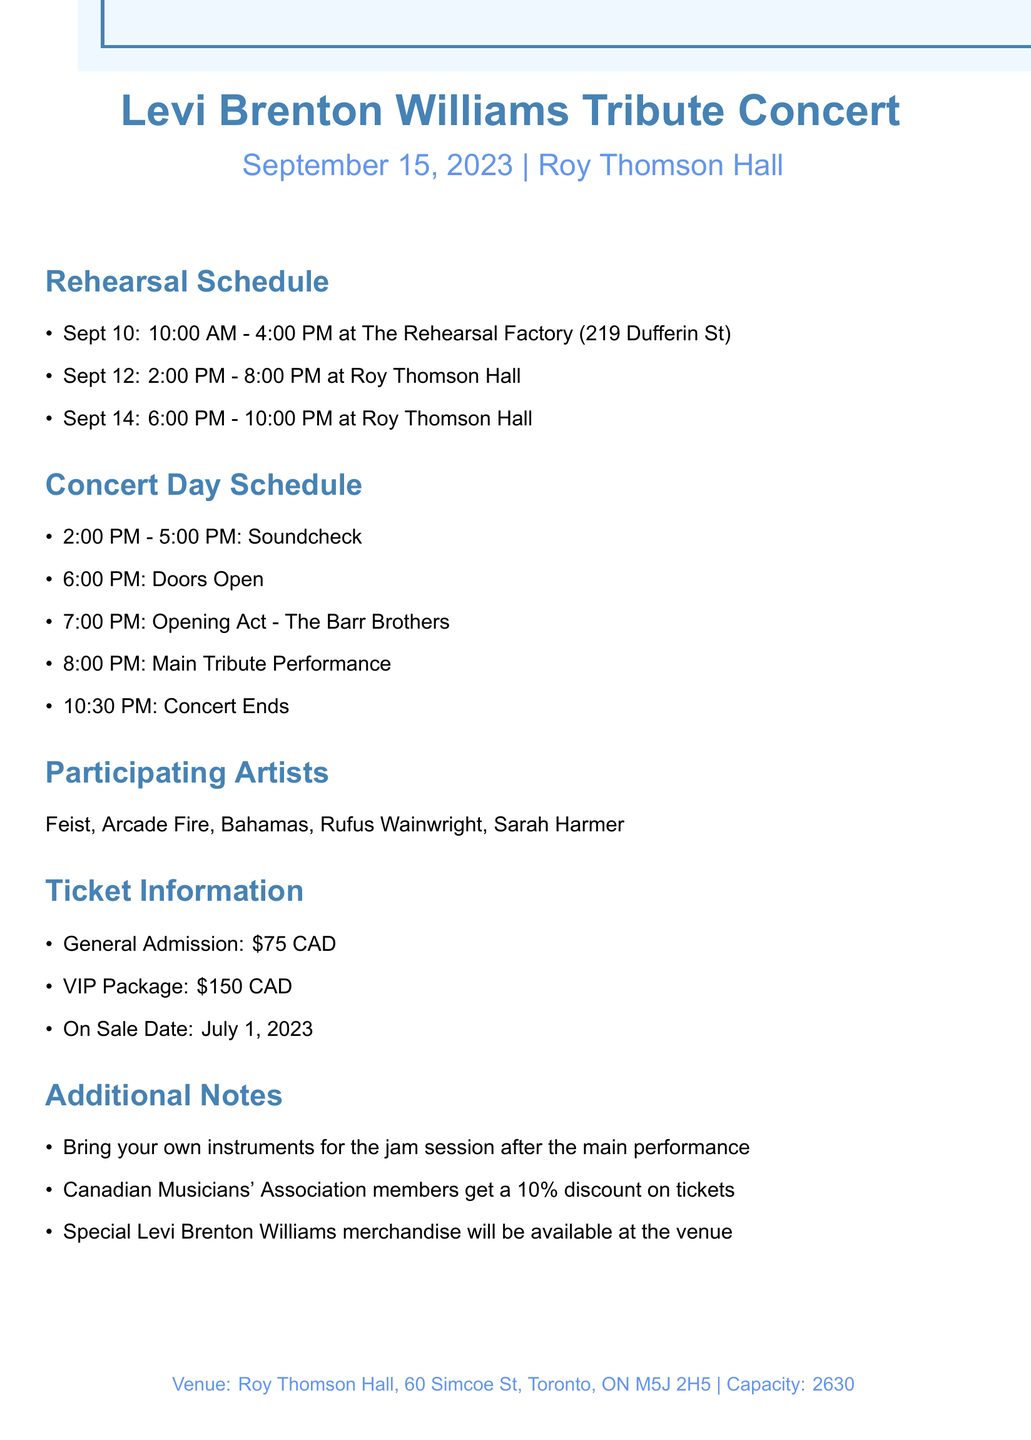what is the concert date? The concert date is specified in the document, which states September 15, 2023.
Answer: September 15, 2023 what is the venue name? The venue name is mentioned in the document as Roy Thomson Hall.
Answer: Roy Thomson Hall how many rehearsals are scheduled before the concert? The document lists three rehearsals scheduled before the concert.
Answer: 3 what time does the doors open? The event schedule indicates that the doors open at 6:00 PM.
Answer: 6:00 PM who is the opening act? The document specifies that The Barr Brothers will be the opening act.
Answer: The Barr Brothers what is the soundcheck duration on concert day? The soundcheck is scheduled from 2:00 PM to 5:00 PM, which gives a duration of three hours.
Answer: 3 hours how much is the general admission ticket? The document states that general admission tickets are priced at $75 CAD.
Answer: $75 CAD what is one of the additional notes for attendees? The document mentions bringing your own instruments for the jam session after the main performance.
Answer: Bring your own instruments what is the capacity of the venue? The concert document indicates that the capacity of Roy Thomson Hall is 2630.
Answer: 2630 